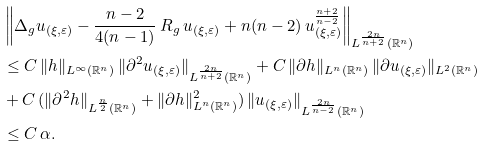Convert formula to latex. <formula><loc_0><loc_0><loc_500><loc_500>& \left \| \Delta _ { g } u _ { ( \xi , \varepsilon ) } - \frac { n - 2 } { 4 ( n - 1 ) } \, R _ { g } \, u _ { ( \xi , \varepsilon ) } + n ( n - 2 ) \, u _ { ( \xi , \varepsilon ) } ^ { \frac { n + 2 } { n - 2 } } \right \| _ { L ^ { \frac { 2 n } { n + 2 } } ( \mathbb { R } ^ { n } ) } \\ & \leq C \, \| h \| _ { L ^ { \infty } ( \mathbb { R } ^ { n } ) } \, \| \partial ^ { 2 } u _ { ( \xi , \varepsilon ) } \| _ { L ^ { \frac { 2 n } { n + 2 } } ( \mathbb { R } ^ { n } ) } + C \, \| \partial h \| _ { L ^ { n } ( \mathbb { R } ^ { n } ) } \, \| \partial u _ { ( \xi , \varepsilon ) } \| _ { L ^ { 2 } ( \mathbb { R } ^ { n } ) } \\ & + C \, ( \| \partial ^ { 2 } h \| _ { L ^ { \frac { n } { 2 } } ( \mathbb { R } ^ { n } ) } + \| \partial h \| _ { L ^ { n } ( \mathbb { R } ^ { n } ) } ^ { 2 } ) \, \| u _ { ( \xi , \varepsilon ) } \| _ { L ^ { \frac { 2 n } { n - 2 } } ( \mathbb { R } ^ { n } ) } \\ & \leq C \, \alpha .</formula> 